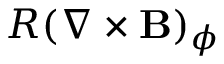Convert formula to latex. <formula><loc_0><loc_0><loc_500><loc_500>R ( \nabla \times \mathbf B ) _ { \phi }</formula> 